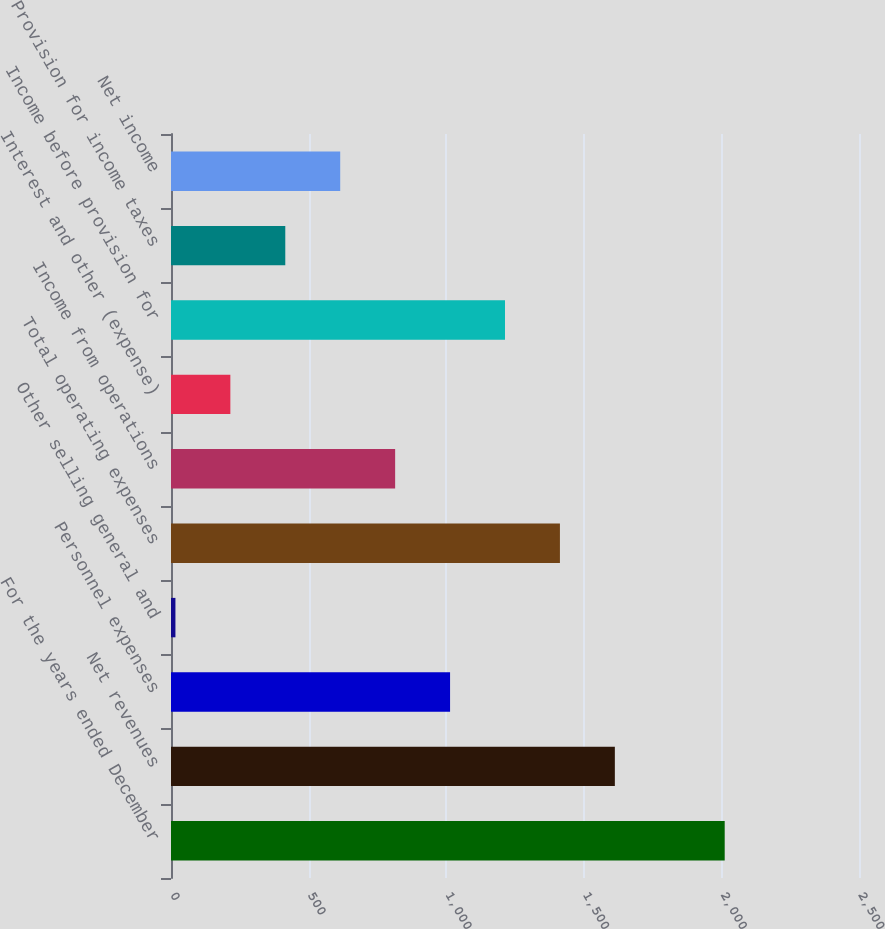Convert chart. <chart><loc_0><loc_0><loc_500><loc_500><bar_chart><fcel>For the years ended December<fcel>Net revenues<fcel>Personnel expenses<fcel>Other selling general and<fcel>Total operating expenses<fcel>Income from operations<fcel>Interest and other (expense)<fcel>Income before provision for<fcel>Provision for income taxes<fcel>Net income<nl><fcel>2012<fcel>1612.82<fcel>1014.05<fcel>16.1<fcel>1413.23<fcel>814.46<fcel>215.69<fcel>1213.64<fcel>415.28<fcel>614.87<nl></chart> 